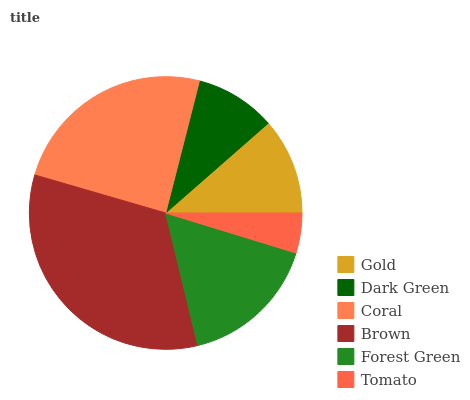Is Tomato the minimum?
Answer yes or no. Yes. Is Brown the maximum?
Answer yes or no. Yes. Is Dark Green the minimum?
Answer yes or no. No. Is Dark Green the maximum?
Answer yes or no. No. Is Gold greater than Dark Green?
Answer yes or no. Yes. Is Dark Green less than Gold?
Answer yes or no. Yes. Is Dark Green greater than Gold?
Answer yes or no. No. Is Gold less than Dark Green?
Answer yes or no. No. Is Forest Green the high median?
Answer yes or no. Yes. Is Gold the low median?
Answer yes or no. Yes. Is Brown the high median?
Answer yes or no. No. Is Tomato the low median?
Answer yes or no. No. 